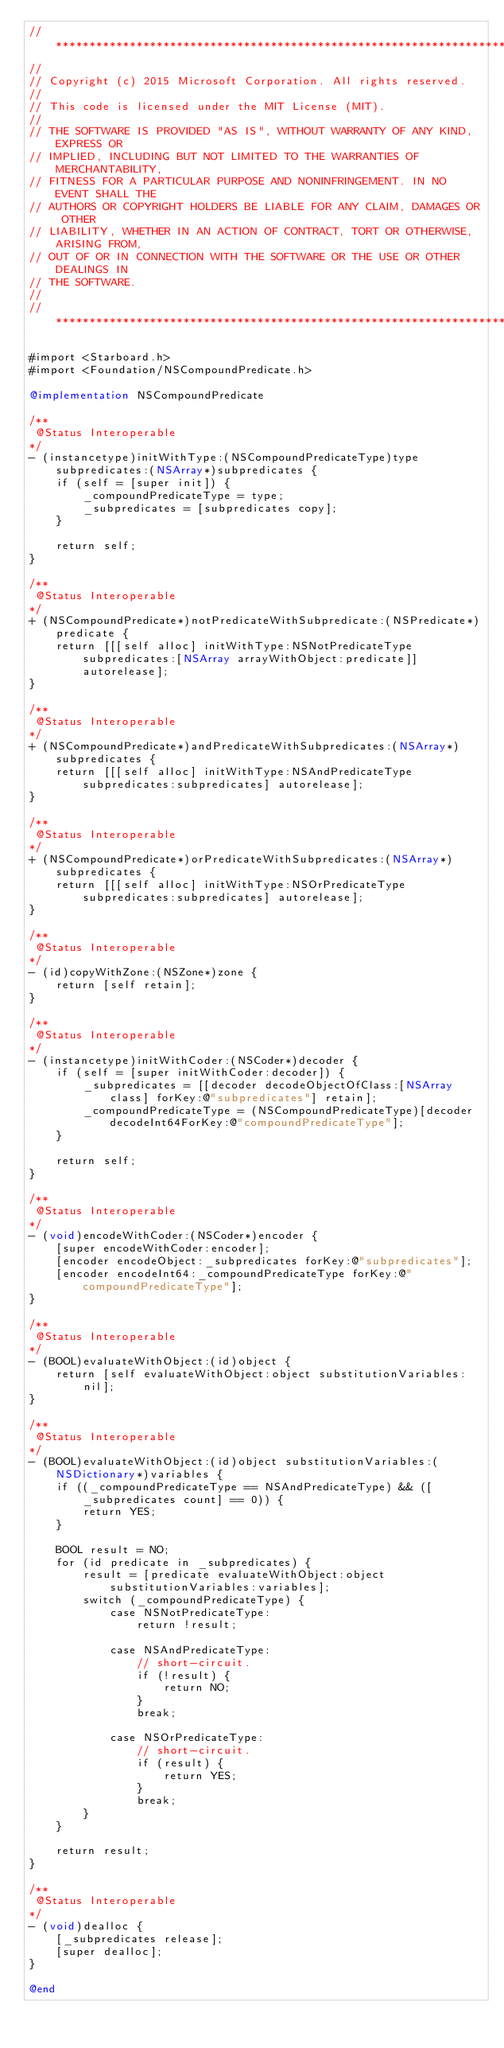<code> <loc_0><loc_0><loc_500><loc_500><_ObjectiveC_>//******************************************************************************
//
// Copyright (c) 2015 Microsoft Corporation. All rights reserved.
//
// This code is licensed under the MIT License (MIT).
//
// THE SOFTWARE IS PROVIDED "AS IS", WITHOUT WARRANTY OF ANY KIND, EXPRESS OR
// IMPLIED, INCLUDING BUT NOT LIMITED TO THE WARRANTIES OF MERCHANTABILITY,
// FITNESS FOR A PARTICULAR PURPOSE AND NONINFRINGEMENT. IN NO EVENT SHALL THE
// AUTHORS OR COPYRIGHT HOLDERS BE LIABLE FOR ANY CLAIM, DAMAGES OR OTHER
// LIABILITY, WHETHER IN AN ACTION OF CONTRACT, TORT OR OTHERWISE, ARISING FROM,
// OUT OF OR IN CONNECTION WITH THE SOFTWARE OR THE USE OR OTHER DEALINGS IN
// THE SOFTWARE.
//
//******************************************************************************

#import <Starboard.h>
#import <Foundation/NSCompoundPredicate.h>

@implementation NSCompoundPredicate

/**
 @Status Interoperable
*/
- (instancetype)initWithType:(NSCompoundPredicateType)type subpredicates:(NSArray*)subpredicates {
    if (self = [super init]) {
        _compoundPredicateType = type;
        _subpredicates = [subpredicates copy];
    }

    return self;
}

/**
 @Status Interoperable
*/
+ (NSCompoundPredicate*)notPredicateWithSubpredicate:(NSPredicate*)predicate {
    return [[[self alloc] initWithType:NSNotPredicateType subpredicates:[NSArray arrayWithObject:predicate]] autorelease];
}

/**
 @Status Interoperable
*/
+ (NSCompoundPredicate*)andPredicateWithSubpredicates:(NSArray*)subpredicates {
    return [[[self alloc] initWithType:NSAndPredicateType subpredicates:subpredicates] autorelease];
}

/**
 @Status Interoperable
*/
+ (NSCompoundPredicate*)orPredicateWithSubpredicates:(NSArray*)subpredicates {
    return [[[self alloc] initWithType:NSOrPredicateType subpredicates:subpredicates] autorelease];
}

/**
 @Status Interoperable
*/
- (id)copyWithZone:(NSZone*)zone {
    return [self retain];
}

/**
 @Status Interoperable
*/
- (instancetype)initWithCoder:(NSCoder*)decoder {
    if (self = [super initWithCoder:decoder]) {
        _subpredicates = [[decoder decodeObjectOfClass:[NSArray class] forKey:@"subpredicates"] retain];
        _compoundPredicateType = (NSCompoundPredicateType)[decoder decodeInt64ForKey:@"compoundPredicateType"];
    }

    return self;
}

/**
 @Status Interoperable
*/
- (void)encodeWithCoder:(NSCoder*)encoder {
    [super encodeWithCoder:encoder];
    [encoder encodeObject:_subpredicates forKey:@"subpredicates"];
    [encoder encodeInt64:_compoundPredicateType forKey:@"compoundPredicateType"];
}

/**
 @Status Interoperable
*/
- (BOOL)evaluateWithObject:(id)object {
    return [self evaluateWithObject:object substitutionVariables:nil];
}

/**
 @Status Interoperable
*/
- (BOOL)evaluateWithObject:(id)object substitutionVariables:(NSDictionary*)variables {
    if ((_compoundPredicateType == NSAndPredicateType) && ([_subpredicates count] == 0)) {
        return YES;
    }

    BOOL result = NO;
    for (id predicate in _subpredicates) {
        result = [predicate evaluateWithObject:object substitutionVariables:variables];
        switch (_compoundPredicateType) {
            case NSNotPredicateType:
                return !result;

            case NSAndPredicateType:
                // short-circuit.
                if (!result) {
                    return NO;
                }
                break;

            case NSOrPredicateType:
                // short-circuit.
                if (result) {
                    return YES;
                }
                break;
        }
    }

    return result;
}

/**
 @Status Interoperable
*/
- (void)dealloc {
    [_subpredicates release];
    [super dealloc];
}

@end</code> 